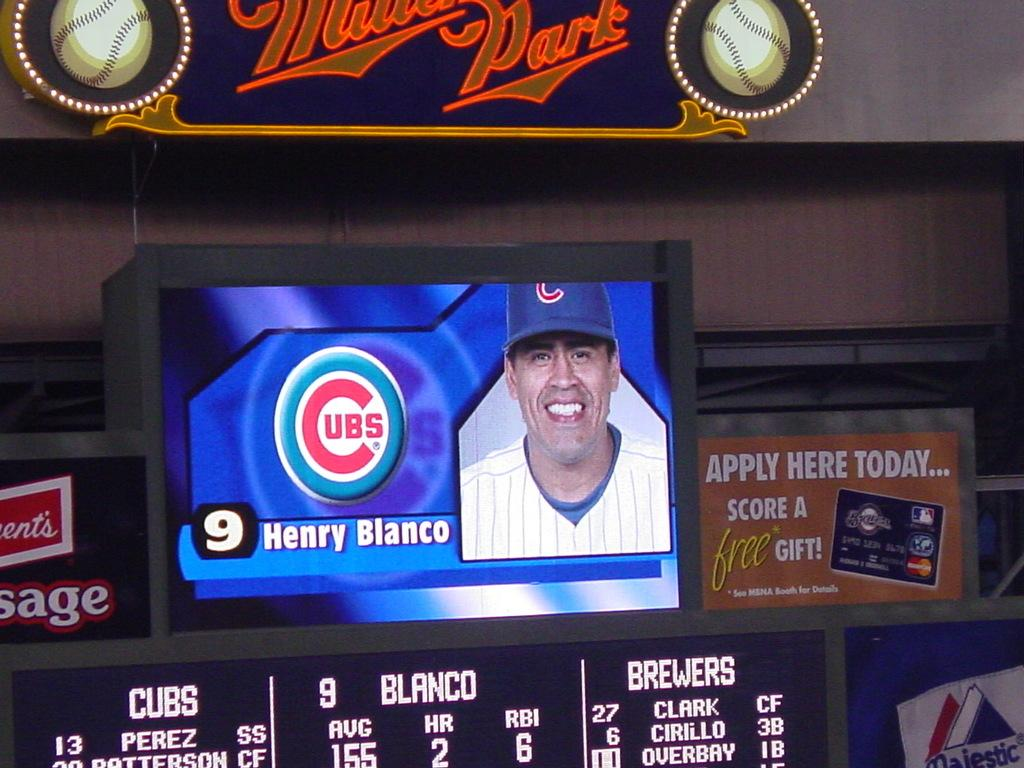<image>
Relay a brief, clear account of the picture shown. A baseball player is featured on a monitor that says Henry Blanco. 